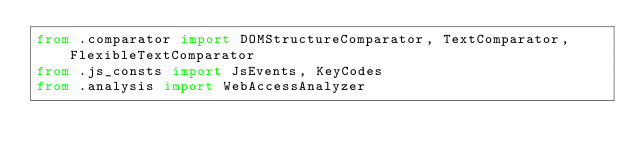<code> <loc_0><loc_0><loc_500><loc_500><_Python_>from .comparator import DOMStructureComparator, TextComparator, FlexibleTextComparator
from .js_consts import JsEvents, KeyCodes
from .analysis import WebAccessAnalyzer
</code> 